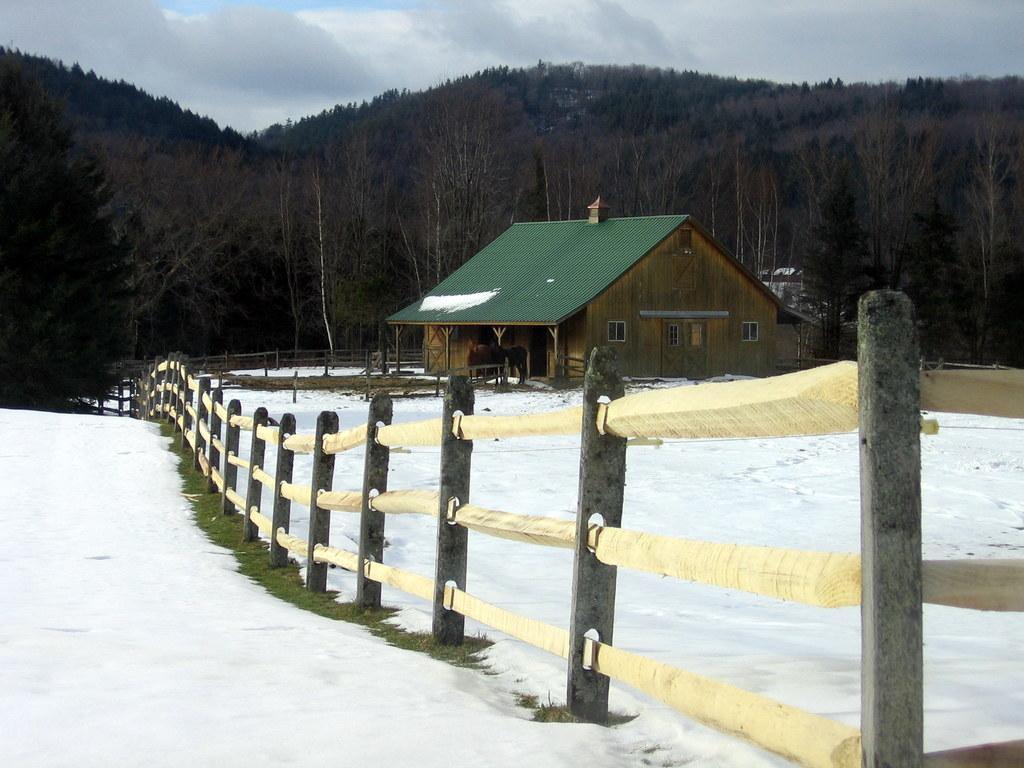Can you describe this image briefly? In the image there is a land covered with snow and on the right side there is a house and around the house there is a fencing. In the background there are plenty of trees. 